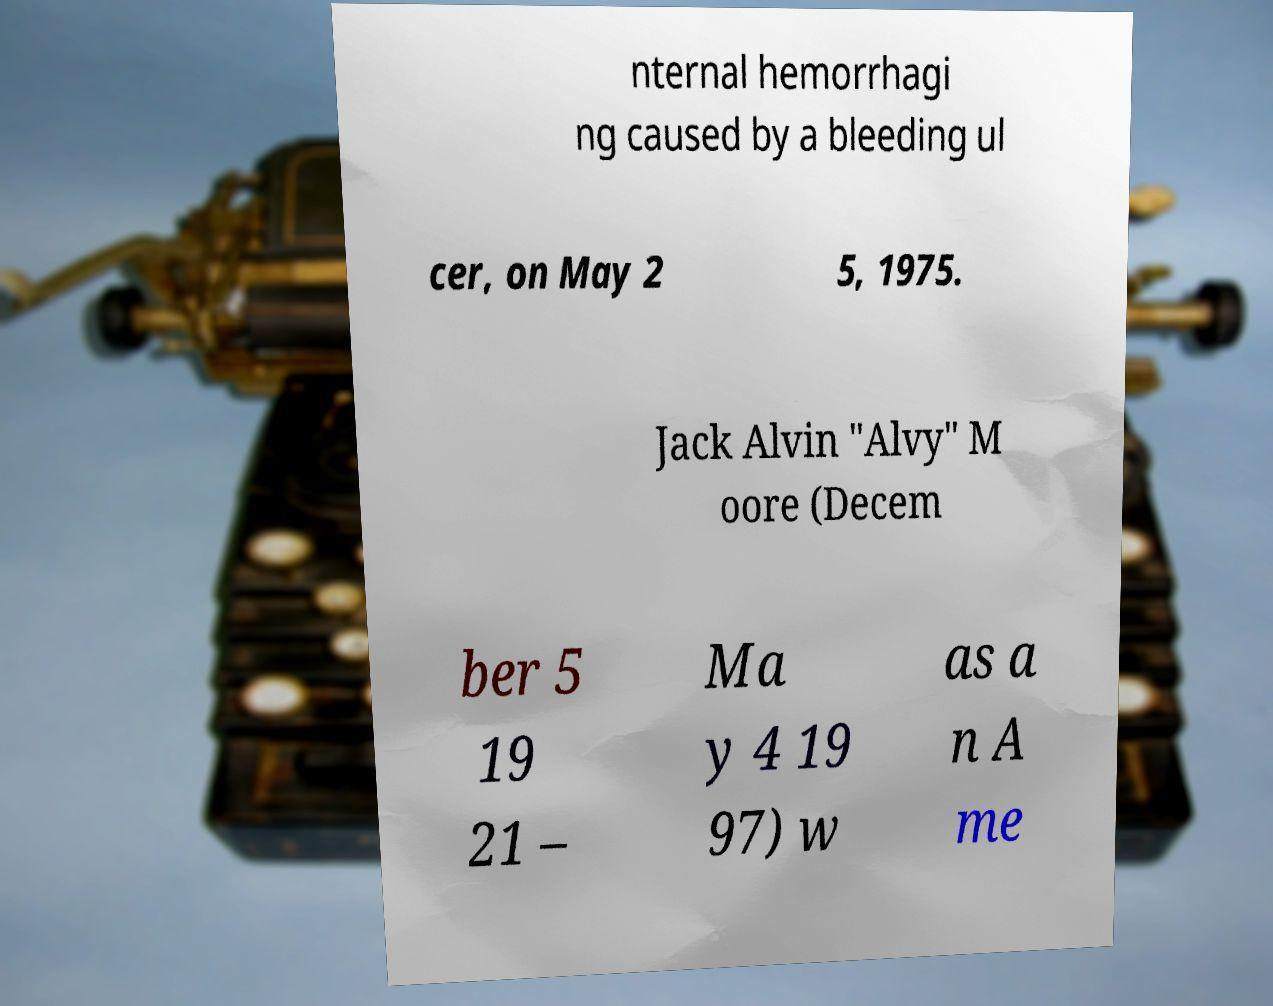What messages or text are displayed in this image? I need them in a readable, typed format. nternal hemorrhagi ng caused by a bleeding ul cer, on May 2 5, 1975. Jack Alvin "Alvy" M oore (Decem ber 5 19 21 – Ma y 4 19 97) w as a n A me 